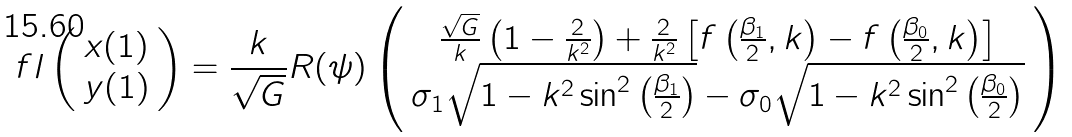Convert formula to latex. <formula><loc_0><loc_0><loc_500><loc_500>\ f l \left ( \begin{array} { c } x ( 1 ) \\ y ( 1 ) \end{array} \right ) = \frac { k } { \sqrt { G } } R ( \psi ) \left ( \begin{array} { c } \frac { \sqrt { G } } { k } \left ( 1 - \frac { 2 } { k ^ { 2 } } \right ) + \frac { 2 } { k ^ { 2 } } \left [ f \left ( \frac { \beta _ { 1 } } { 2 } , k \right ) - f \left ( \frac { \beta _ { 0 } } { 2 } , k \right ) \right ] \\ \sigma _ { 1 } \sqrt { 1 - k ^ { 2 } \sin ^ { 2 } \left ( \frac { \beta _ { 1 } } { 2 } \right ) } - \sigma _ { 0 } \sqrt { 1 - k ^ { 2 } \sin ^ { 2 } \left ( \frac { \beta _ { 0 } } { 2 } \right ) } \end{array} \right )</formula> 